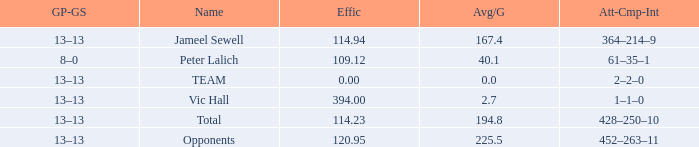Avg/G that has a GP-GS of 13–13, and a Effic smaller than 114.23 has what total of numbers? 1.0. 